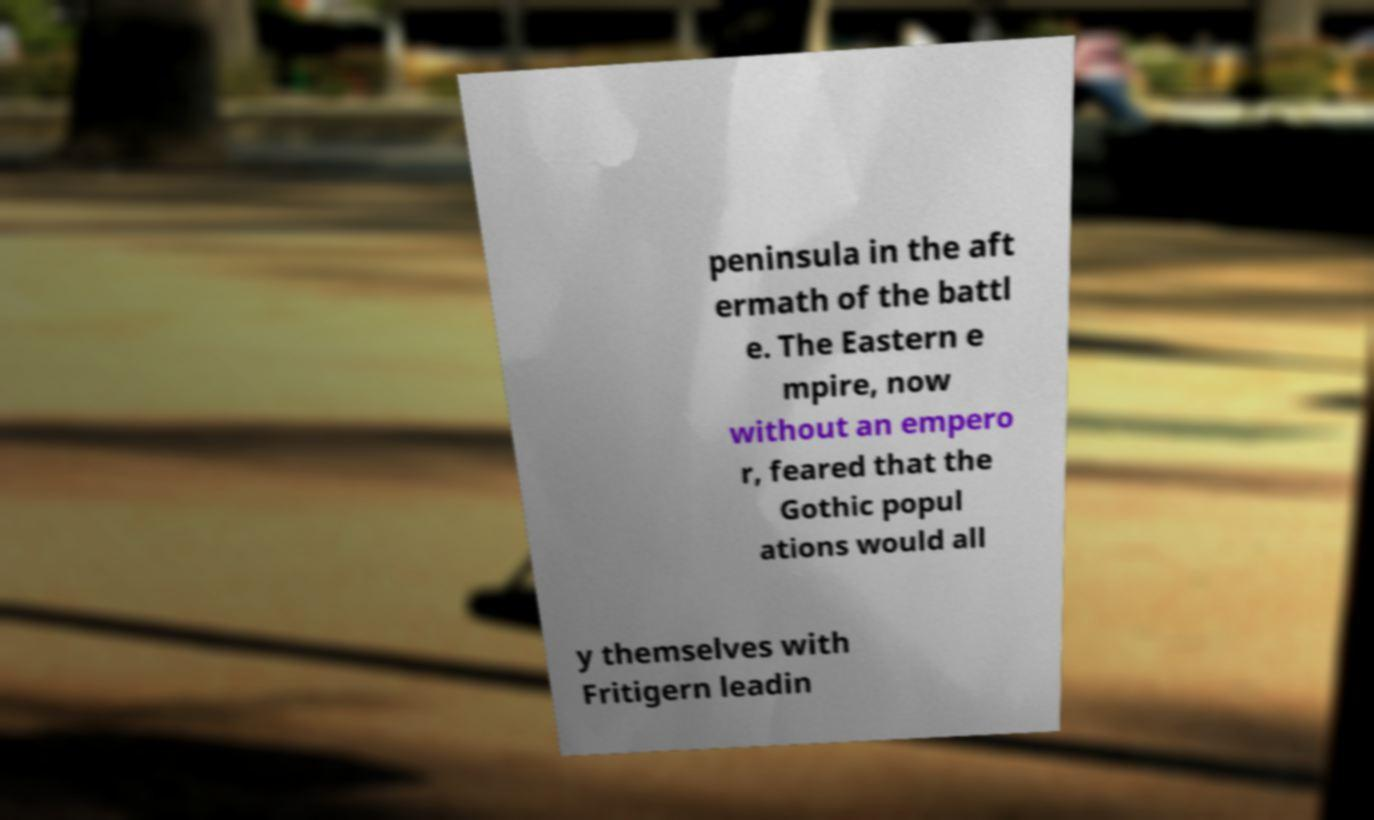Please identify and transcribe the text found in this image. peninsula in the aft ermath of the battl e. The Eastern e mpire, now without an empero r, feared that the Gothic popul ations would all y themselves with Fritigern leadin 